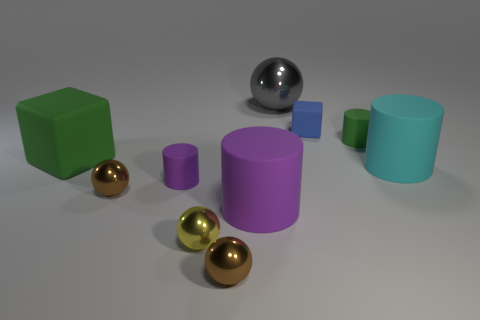Subtract all big metallic spheres. How many spheres are left? 3 Subtract all gray balls. How many balls are left? 3 Subtract all purple spheres. How many purple cylinders are left? 2 Subtract all cylinders. How many objects are left? 6 Subtract 1 cylinders. How many cylinders are left? 3 Subtract 0 purple spheres. How many objects are left? 10 Subtract all blue spheres. Subtract all purple blocks. How many spheres are left? 4 Subtract all green rubber things. Subtract all large gray spheres. How many objects are left? 7 Add 6 purple matte things. How many purple matte things are left? 8 Add 3 cyan matte cylinders. How many cyan matte cylinders exist? 4 